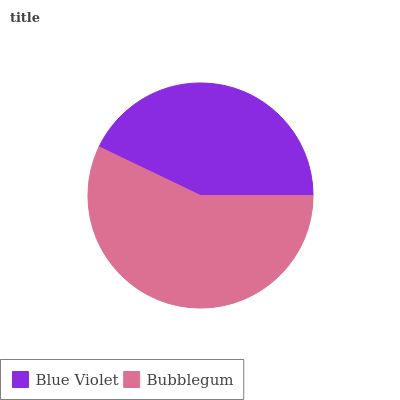Is Blue Violet the minimum?
Answer yes or no. Yes. Is Bubblegum the maximum?
Answer yes or no. Yes. Is Bubblegum the minimum?
Answer yes or no. No. Is Bubblegum greater than Blue Violet?
Answer yes or no. Yes. Is Blue Violet less than Bubblegum?
Answer yes or no. Yes. Is Blue Violet greater than Bubblegum?
Answer yes or no. No. Is Bubblegum less than Blue Violet?
Answer yes or no. No. Is Bubblegum the high median?
Answer yes or no. Yes. Is Blue Violet the low median?
Answer yes or no. Yes. Is Blue Violet the high median?
Answer yes or no. No. Is Bubblegum the low median?
Answer yes or no. No. 